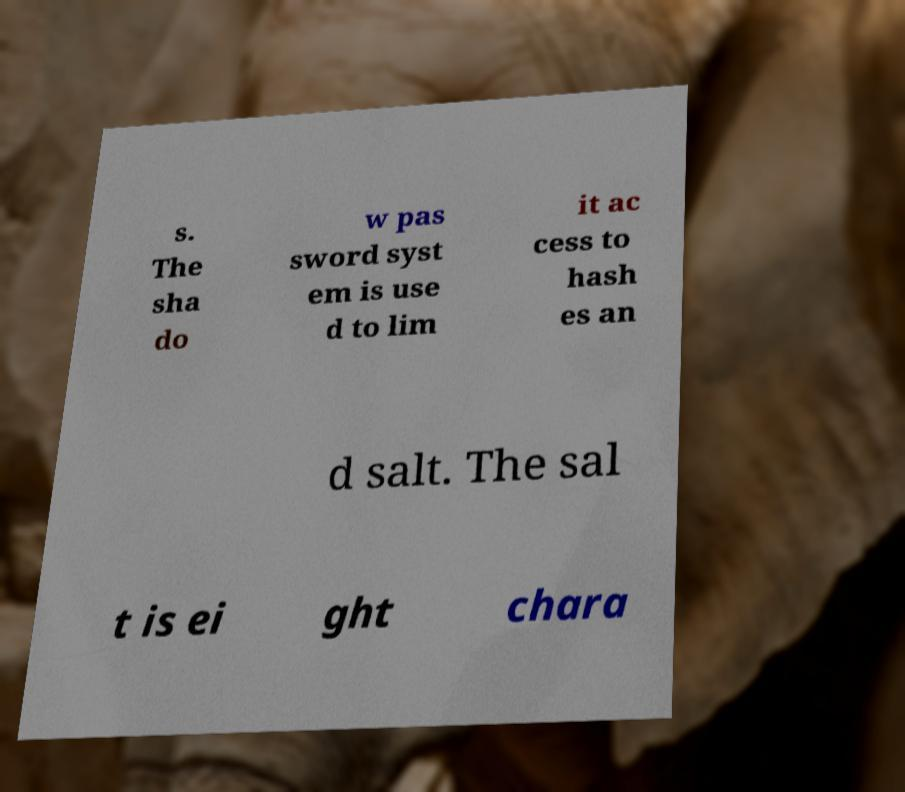I need the written content from this picture converted into text. Can you do that? s. The sha do w pas sword syst em is use d to lim it ac cess to hash es an d salt. The sal t is ei ght chara 